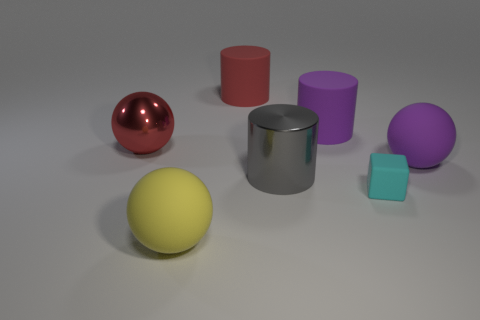Subtract all purple spheres. How many spheres are left? 2 Subtract all metal cylinders. How many cylinders are left? 2 Subtract 1 red balls. How many objects are left? 6 Subtract all balls. How many objects are left? 4 Subtract 1 blocks. How many blocks are left? 0 Subtract all red cubes. Subtract all brown cylinders. How many cubes are left? 1 Subtract all green balls. How many red cylinders are left? 1 Subtract all gray metallic cylinders. Subtract all large purple things. How many objects are left? 4 Add 2 purple rubber things. How many purple rubber things are left? 4 Add 2 purple cylinders. How many purple cylinders exist? 3 